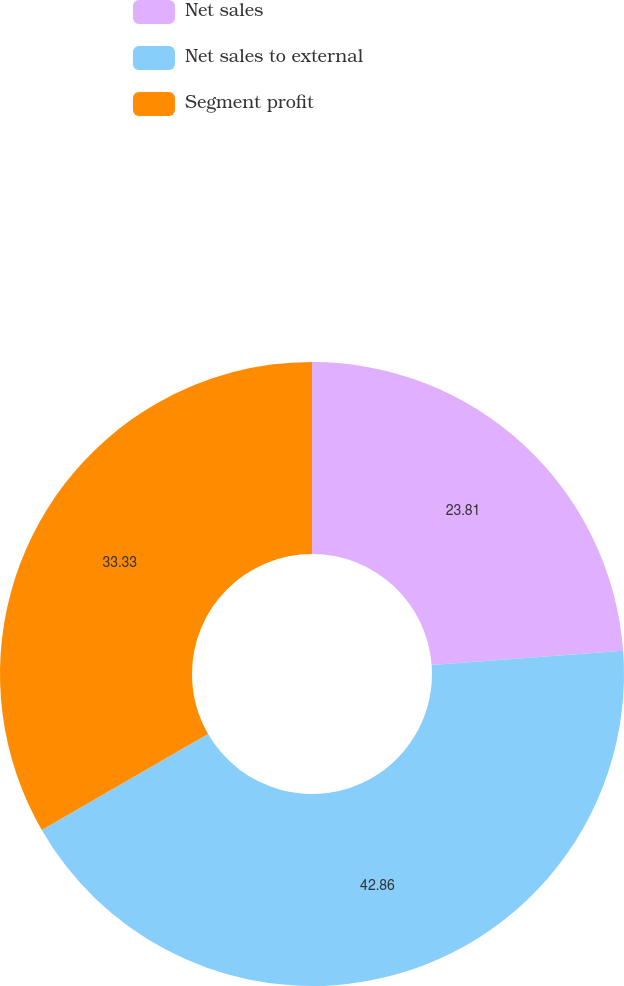<chart> <loc_0><loc_0><loc_500><loc_500><pie_chart><fcel>Net sales<fcel>Net sales to external<fcel>Segment profit<nl><fcel>23.81%<fcel>42.86%<fcel>33.33%<nl></chart> 